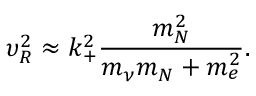<formula> <loc_0><loc_0><loc_500><loc_500>\upsilon _ { R } ^ { 2 } \approx k _ { + } ^ { 2 } \frac { m _ { N } ^ { 2 } } { m _ { \nu } m _ { N } + m _ { e } ^ { 2 } } .</formula> 